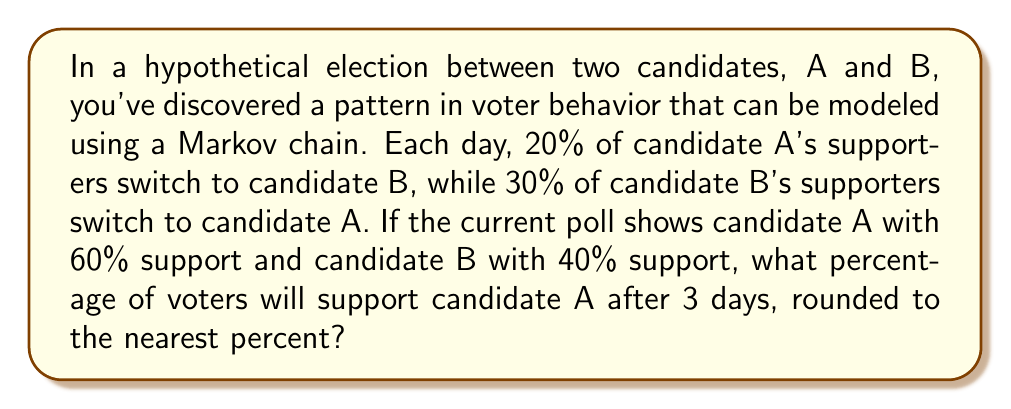Can you answer this question? Let's approach this step-by-step using a Markov chain model:

1) First, we need to set up the transition matrix. Let $P$ be the probability of staying with the same candidate, and $Q$ be the probability of switching:

   For A: $P_A = 0.8$, $Q_A = 0.2$
   For B: $P_B = 0.7$, $Q_B = 0.3$

   The transition matrix $T$ is:

   $$T = \begin{bmatrix} 
   0.8 & 0.3 \\
   0.2 & 0.7
   \end{bmatrix}$$

2) The initial state vector $S_0$ is:

   $$S_0 = \begin{bmatrix}
   0.6 \\
   0.4
   \end{bmatrix}$$

3) To find the state after 3 days, we need to multiply the initial state by the transition matrix 3 times:

   $$S_3 = T^3 \cdot S_0$$

4) Let's calculate $T^3$:

   $$T^2 = \begin{bmatrix}
   0.7 & 0.45 \\
   0.3 & 0.55
   \end{bmatrix}$$

   $$T^3 = \begin{bmatrix}
   0.67 & 0.525 \\
   0.33 & 0.475
   \end{bmatrix}$$

5) Now we can calculate $S_3$:

   $$S_3 = \begin{bmatrix}
   0.67 & 0.525 \\
   0.33 & 0.475
   \end{bmatrix} \cdot \begin{bmatrix}
   0.6 \\
   0.4
   \end{bmatrix} = \begin{bmatrix}
   0.612 \\
   0.388
   \end{bmatrix}$$

6) The first element of $S_3$ represents the proportion of voters supporting candidate A after 3 days.

7) 0.612 rounded to the nearest percent is 61%.
Answer: 61% 